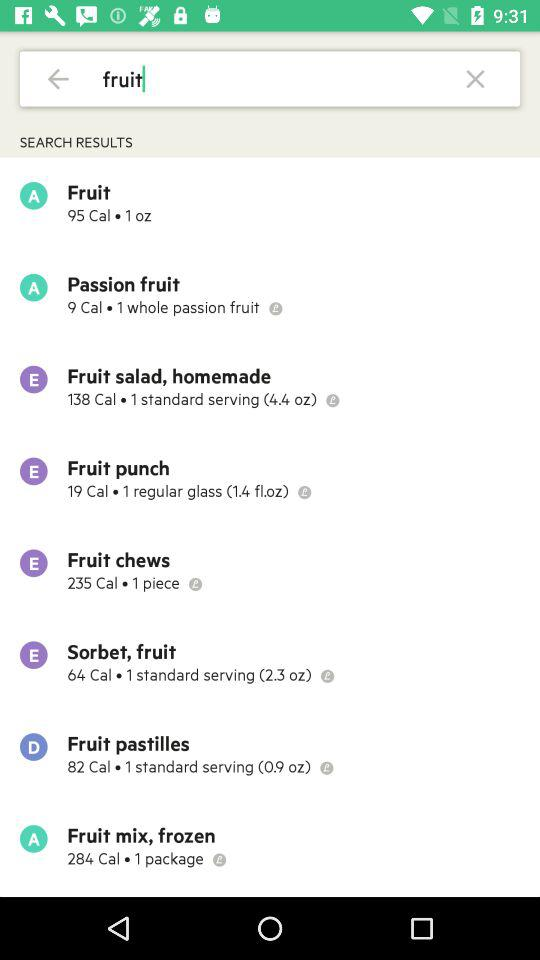How many calories are in "Fruit chews"? There are 235 calories in "Fruit chews". 